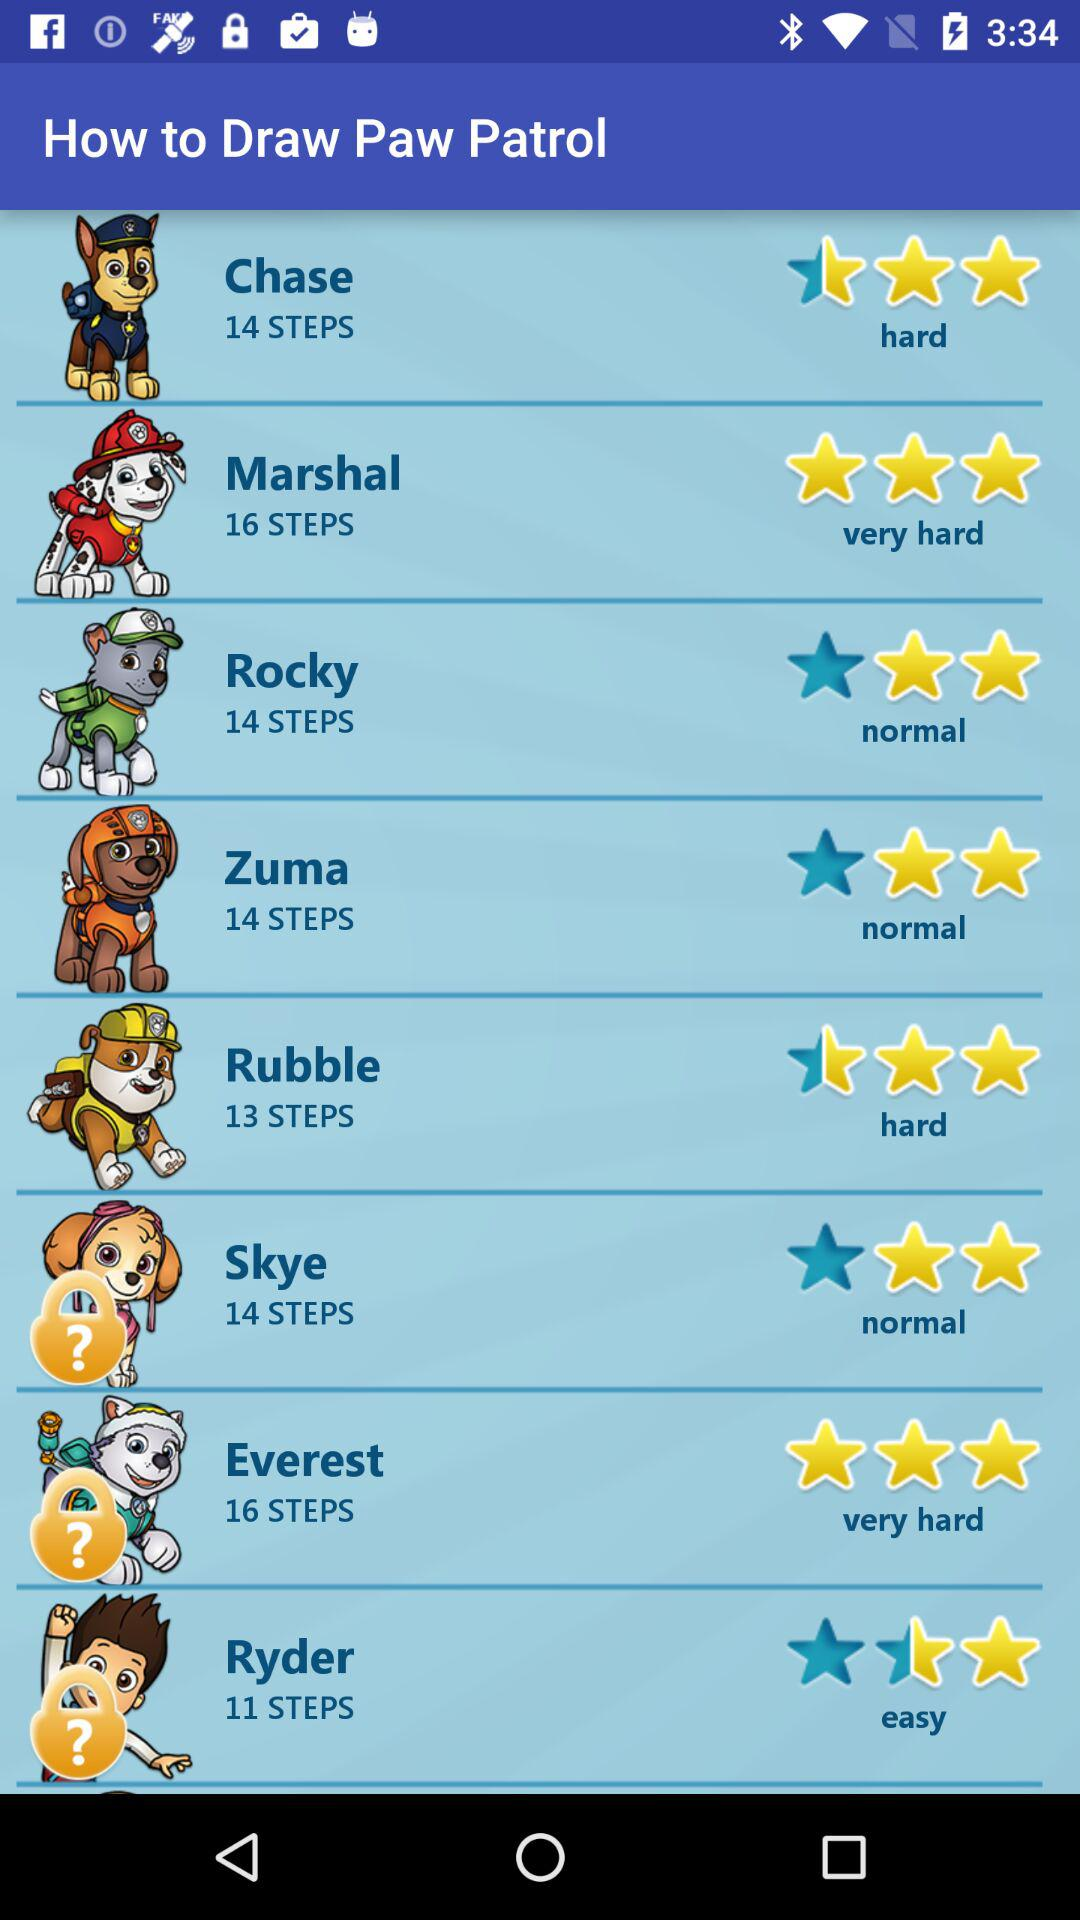How difficult is it to draw Marshal? It is very hard to draw Marshal. 